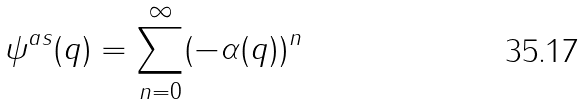Convert formula to latex. <formula><loc_0><loc_0><loc_500><loc_500>\psi ^ { a s } ( q ) = \sum _ { n = 0 } ^ { \infty } ( - \alpha ( q ) ) ^ { n }</formula> 